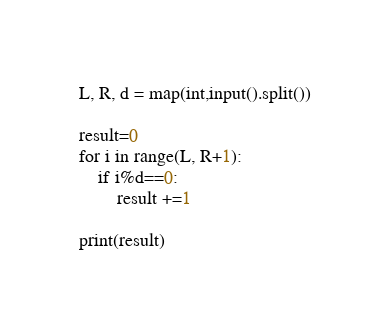<code> <loc_0><loc_0><loc_500><loc_500><_Python_>L, R, d = map(int,input().split())

result=0
for i in range(L, R+1):
    if i%d==0:
        result +=1

print(result)</code> 